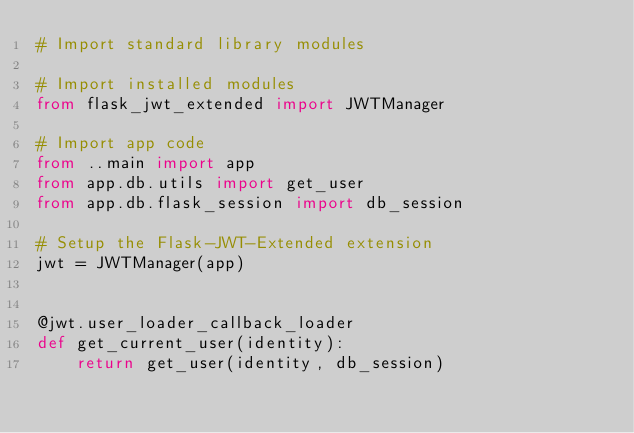Convert code to text. <code><loc_0><loc_0><loc_500><loc_500><_Python_># Import standard library modules

# Import installed modules
from flask_jwt_extended import JWTManager

# Import app code
from ..main import app
from app.db.utils import get_user
from app.db.flask_session import db_session

# Setup the Flask-JWT-Extended extension
jwt = JWTManager(app)


@jwt.user_loader_callback_loader
def get_current_user(identity):
    return get_user(identity, db_session)
</code> 